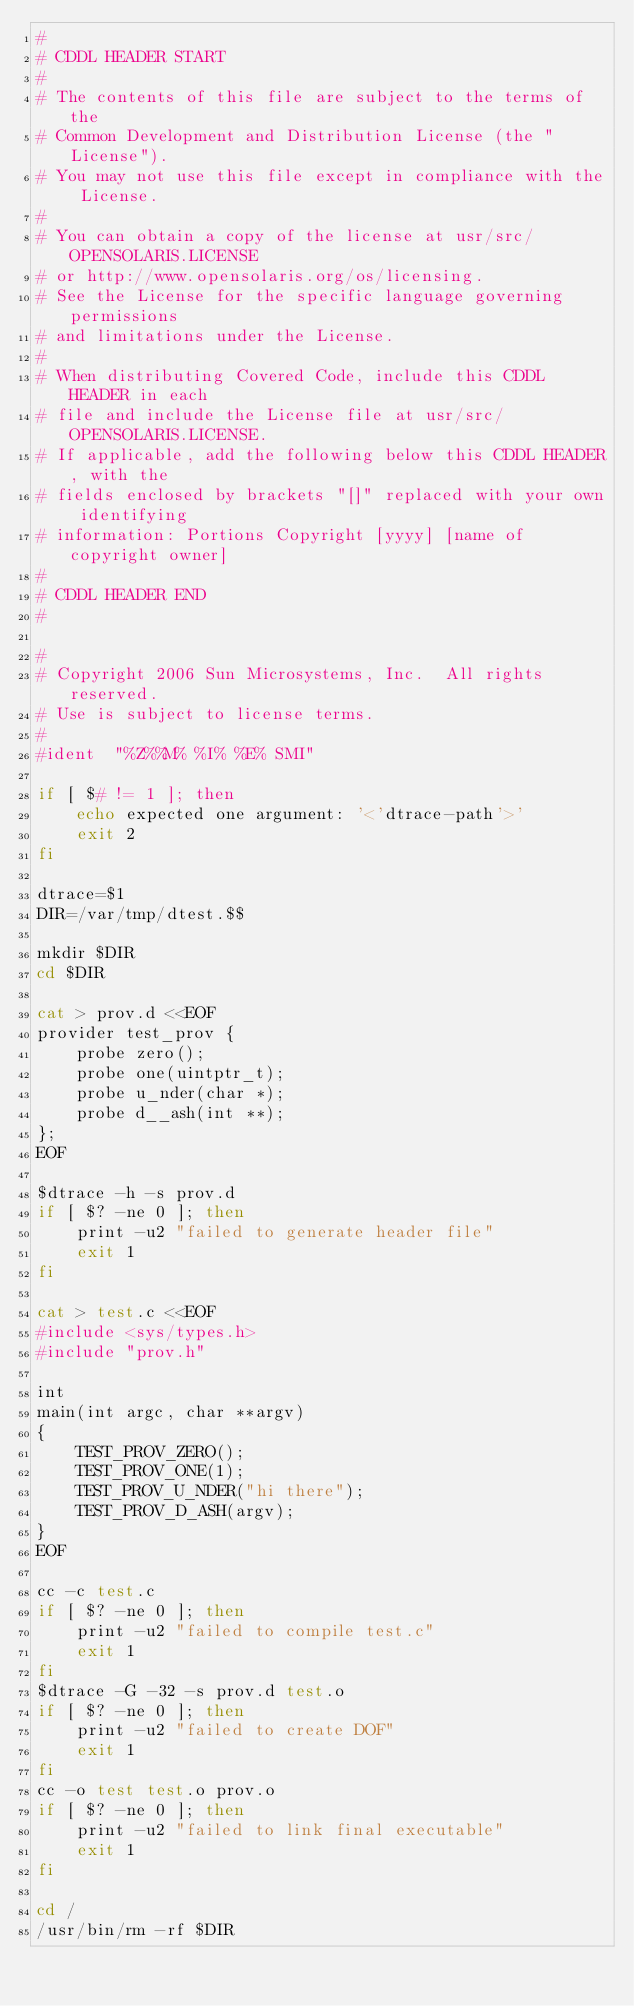Convert code to text. <code><loc_0><loc_0><loc_500><loc_500><_Bash_>#
# CDDL HEADER START
#
# The contents of this file are subject to the terms of the
# Common Development and Distribution License (the "License").
# You may not use this file except in compliance with the License.
#
# You can obtain a copy of the license at usr/src/OPENSOLARIS.LICENSE
# or http://www.opensolaris.org/os/licensing.
# See the License for the specific language governing permissions
# and limitations under the License.
#
# When distributing Covered Code, include this CDDL HEADER in each
# file and include the License file at usr/src/OPENSOLARIS.LICENSE.
# If applicable, add the following below this CDDL HEADER, with the
# fields enclosed by brackets "[]" replaced with your own identifying
# information: Portions Copyright [yyyy] [name of copyright owner]
#
# CDDL HEADER END
#

#
# Copyright 2006 Sun Microsystems, Inc.  All rights reserved.
# Use is subject to license terms.
#
#ident	"%Z%%M%	%I%	%E% SMI"

if [ $# != 1 ]; then
	echo expected one argument: '<'dtrace-path'>'
	exit 2
fi

dtrace=$1
DIR=/var/tmp/dtest.$$

mkdir $DIR
cd $DIR

cat > prov.d <<EOF
provider test_prov {
	probe zero();
	probe one(uintptr_t);
	probe u_nder(char *);
	probe d__ash(int **);
};
EOF

$dtrace -h -s prov.d
if [ $? -ne 0 ]; then
	print -u2 "failed to generate header file"
	exit 1
fi

cat > test.c <<EOF
#include <sys/types.h>
#include "prov.h"

int
main(int argc, char **argv)
{
	TEST_PROV_ZERO();
	TEST_PROV_ONE(1);
	TEST_PROV_U_NDER("hi there");
	TEST_PROV_D_ASH(argv);
}
EOF

cc -c test.c
if [ $? -ne 0 ]; then
	print -u2 "failed to compile test.c"
	exit 1
fi
$dtrace -G -32 -s prov.d test.o
if [ $? -ne 0 ]; then
	print -u2 "failed to create DOF"
	exit 1
fi
cc -o test test.o prov.o
if [ $? -ne 0 ]; then
	print -u2 "failed to link final executable"
	exit 1
fi

cd /
/usr/bin/rm -rf $DIR
</code> 